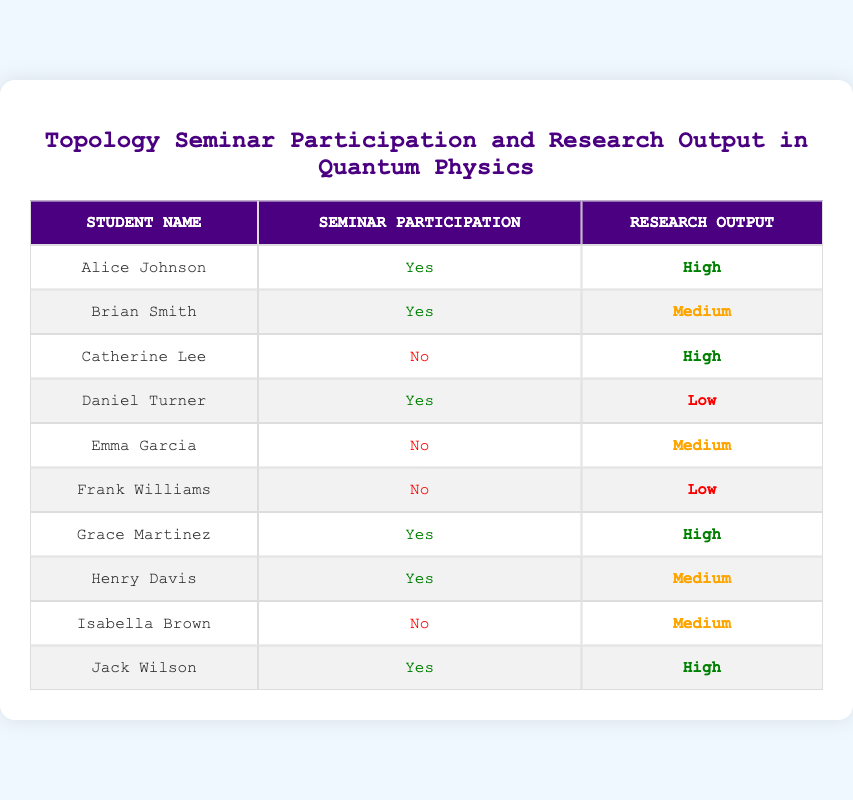What percentage of students who participated in seminars had a high research output? There are 4 students who participated in seminars, and out of them, 3 (Alice Johnson, Grace Martinez, and Jack Wilson) had a high research output. To find the percentage, we use the formula (number of students with high output / total number of participating students) * 100. This results in (3 / 4) * 100 = 75%.
Answer: 75% How many students did not participate in seminars? The table lists 10 students in total. To find the number of students who did not participate in seminars, we can count the rows where Participation is marked as "No". There are 4 students (Catherine Lee, Emma Garcia, Frank Williams, and Isabella Brown) who did not participate.
Answer: 4 What is the average research output of students who participated in seminars? The students who participated in seminars have the following research outputs: High (3 times), Medium (1 time), and Low (1 time). To calculate the average, we can assign numerical values: High = 3, Medium = 2, Low = 1, giving us a total of (3 + 2 + 1 + 3 + 2) = 11 from the 5 responses. Then we find the average, which is 11 / 5 = 2.2. This indicates that on average, the research output is between Medium and High.
Answer: 2.2 Is there any student who participated in the seminar but had low research output? Looking at the table, Daniel Turner is the only student who participated in the seminar and had low research output. Thus, the answer is yes, there is at least one student fitting this description.
Answer: Yes What is the ratio of students with high research output to those with medium research output who participated in seminars? From the data, there are 3 students with high research output (Alice Johnson, Grace Martinez, and Jack Wilson) and 1 student with medium research output (Henry Davis) among those who participated. Hence, the ratio of high to medium research output is 3:1.
Answer: 3:1 